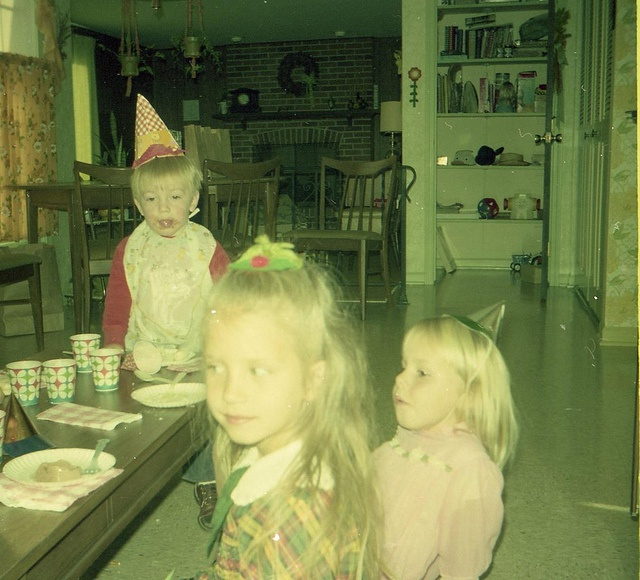Describe the objects in this image and their specific colors. I can see people in khaki and olive tones, dining table in khaki, darkgreen, and olive tones, people in khaki and tan tones, people in khaki, tan, brown, and olive tones, and chair in khaki, black, darkgreen, and olive tones in this image. 